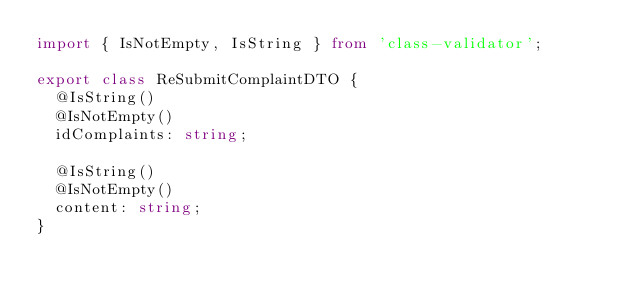<code> <loc_0><loc_0><loc_500><loc_500><_TypeScript_>import { IsNotEmpty, IsString } from 'class-validator';

export class ReSubmitComplaintDTO {
  @IsString()
  @IsNotEmpty()
  idComplaints: string;

  @IsString()
  @IsNotEmpty()
  content: string;
}
</code> 